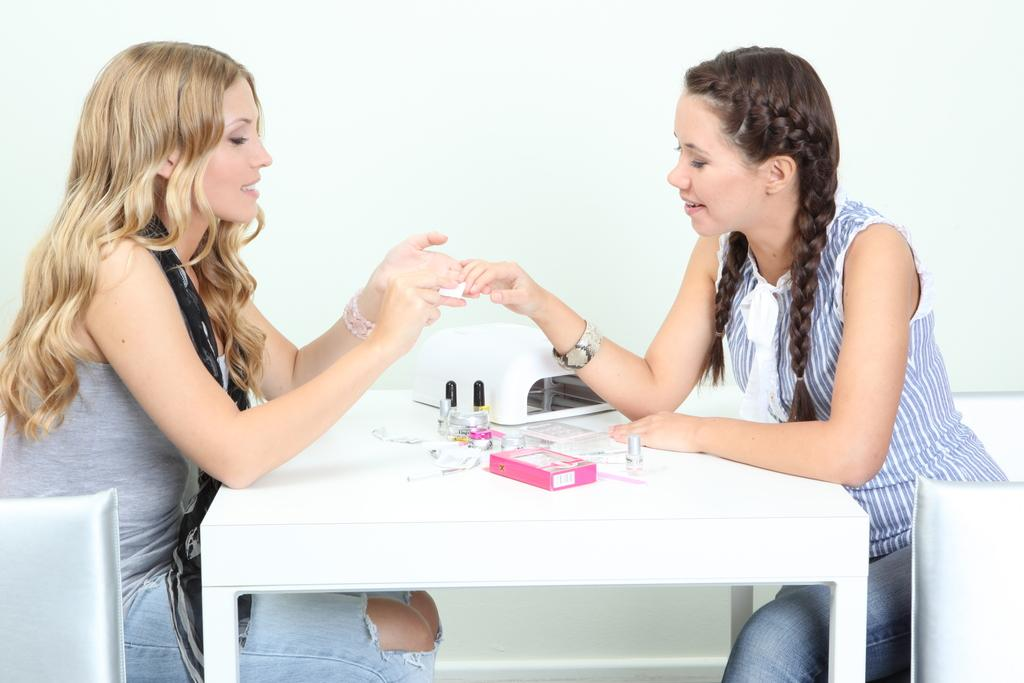What is the woman doing in the image? The woman is sitting on a chair in the image. What is in front of the woman? There is a table in front of the woman. What can be seen on the table? There are objects on the table. Who is sitting opposite the woman? There is a girl sitting opposite the woman. What is the girl's expression? The girl is smiling. What can be seen in the background of the image? There is a wall visible in the image. How many pigs are sitting on the cushion in the image? There are no pigs or cushions present in the image. 